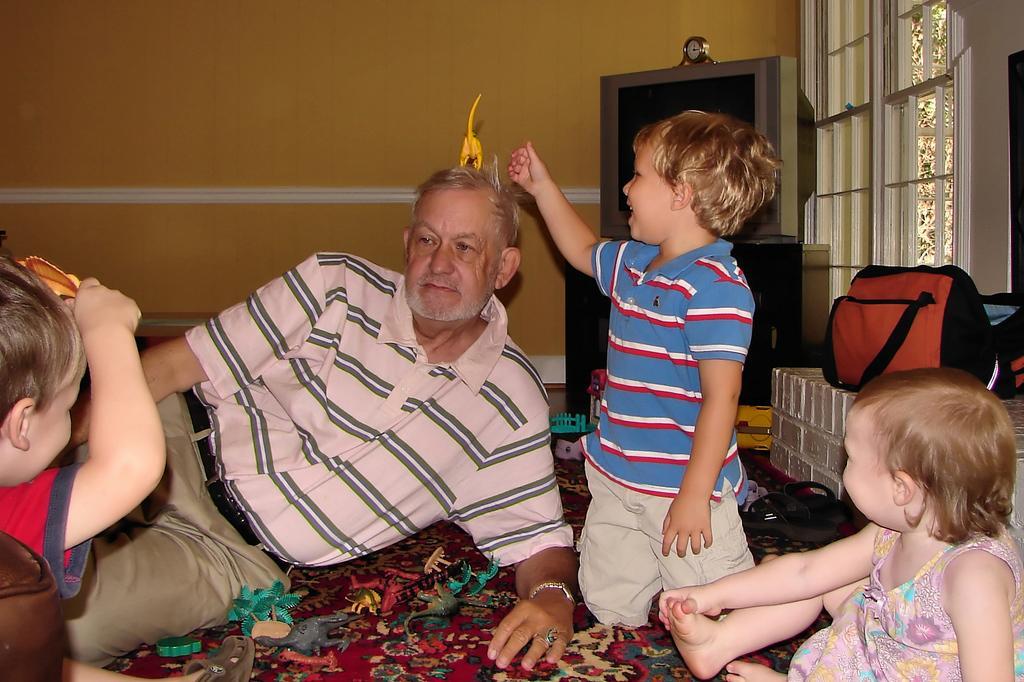Describe this image in one or two sentences. In this image I can see group of people. In front the person is wearing pink and cream color dress and the person at right is wearing blue and cream color dress and I can also see few toys in multicolor. Background I can see a bag in orange and black color. I can also see a television, few windows and the wall is in yellow color. 